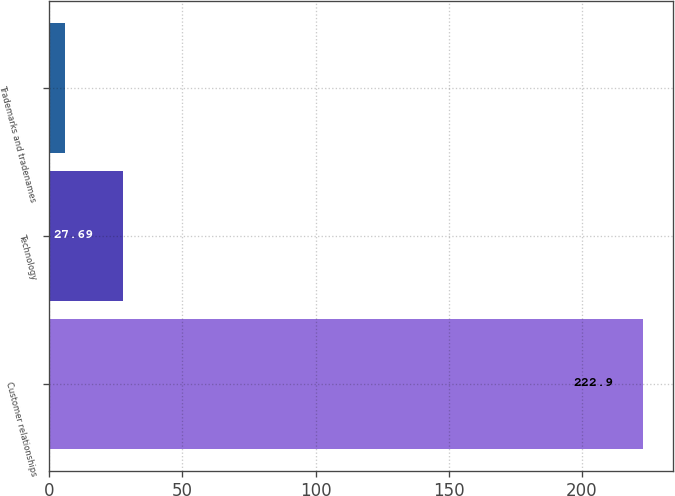Convert chart to OTSL. <chart><loc_0><loc_0><loc_500><loc_500><bar_chart><fcel>Customer relationships<fcel>Technology<fcel>Trademarks and tradenames<nl><fcel>222.9<fcel>27.69<fcel>6<nl></chart> 